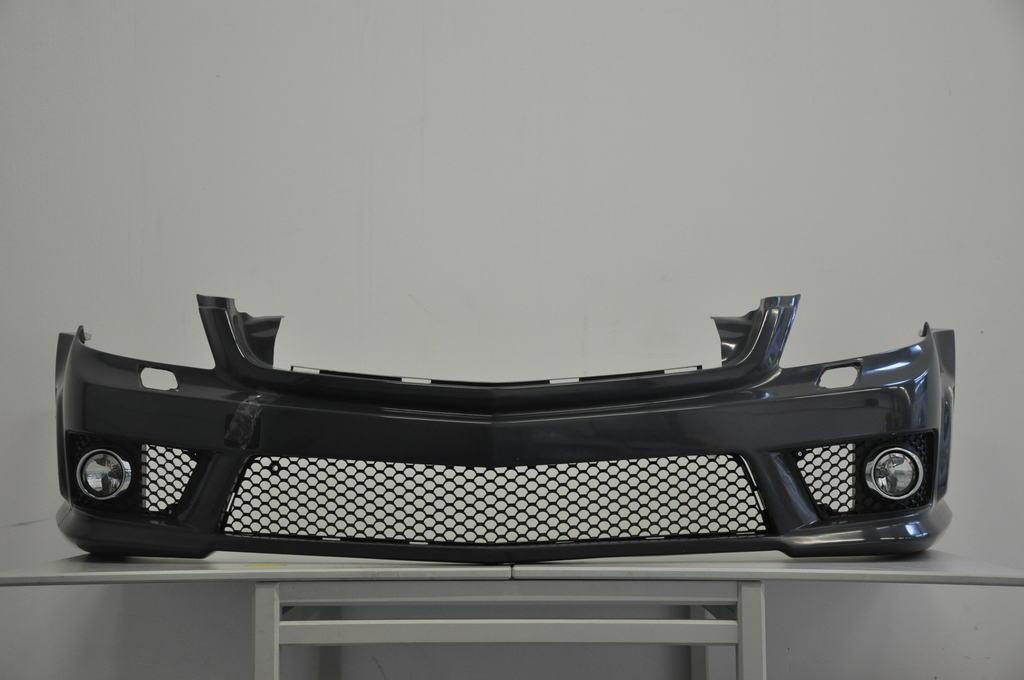What piece of furniture is present in the image? There is a table in the image. Where is the table located in relation to the image? The table is towards the bottom of the image. What is on top of the table? There is a grille on the table. What can be seen in the background of the image? There is a wall in the background of the image. What type of apparatus is used by the father to overcome his fear in the image? There is no apparatus, father, or fear present in the image. 